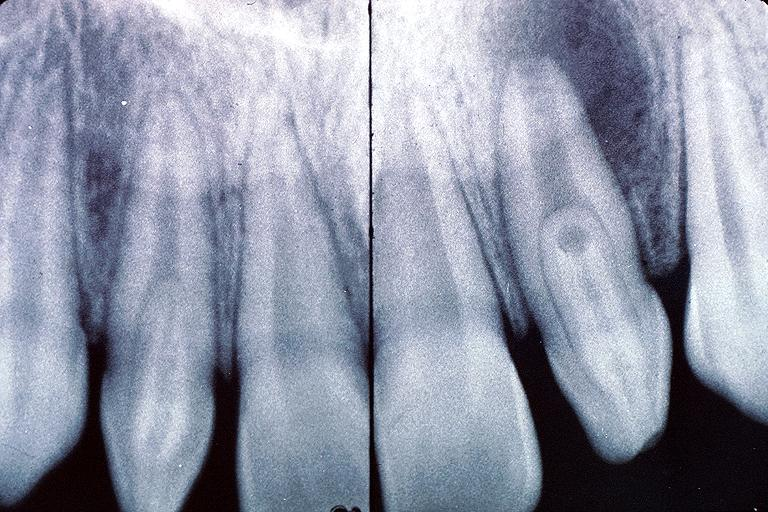s oral present?
Answer the question using a single word or phrase. Yes 